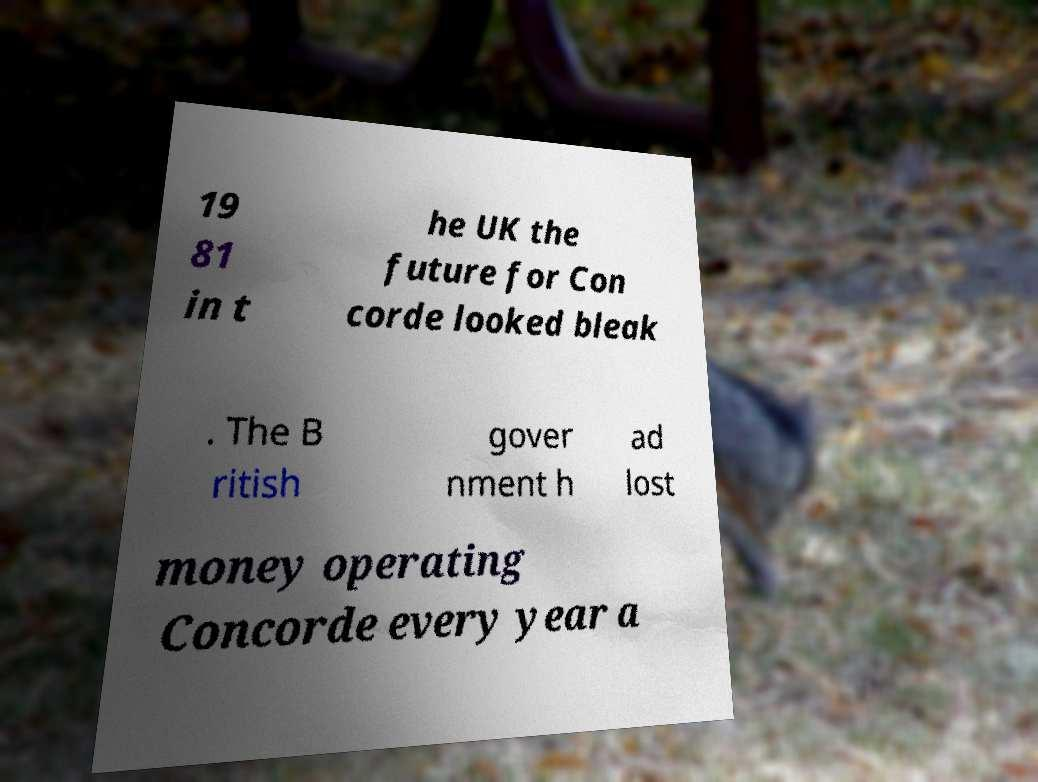For documentation purposes, I need the text within this image transcribed. Could you provide that? 19 81 in t he UK the future for Con corde looked bleak . The B ritish gover nment h ad lost money operating Concorde every year a 